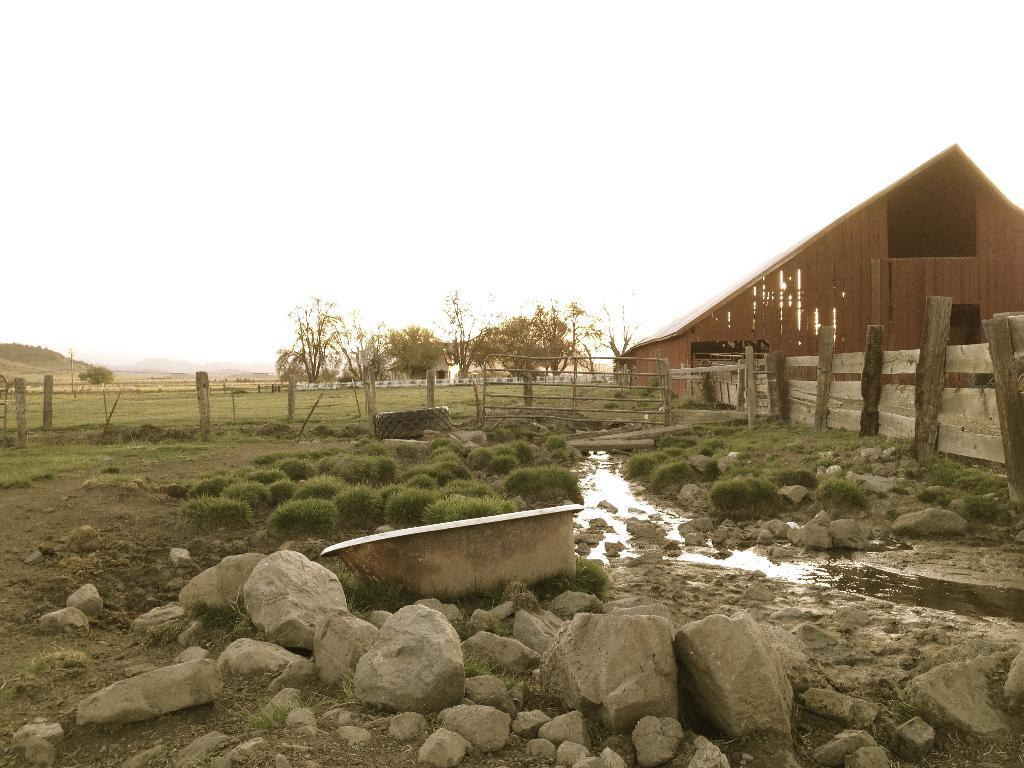What type of objects can be seen in the image? There are stones, a tub, and a wooden fence in the image. What type of vegetation is present in the image? There is grass in the image, and trees can be seen in the background. What structure is located on the right side of the image? There is a shed on the right side of the image. What can be seen in the background of the image? Trees and the sky are visible in the background of the image. What type of animal is seen bursting through the wooden fence in the image? There is no animal present in the image, nor is there any indication of something bursting through the wooden fence. 